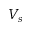Convert formula to latex. <formula><loc_0><loc_0><loc_500><loc_500>V _ { s }</formula> 